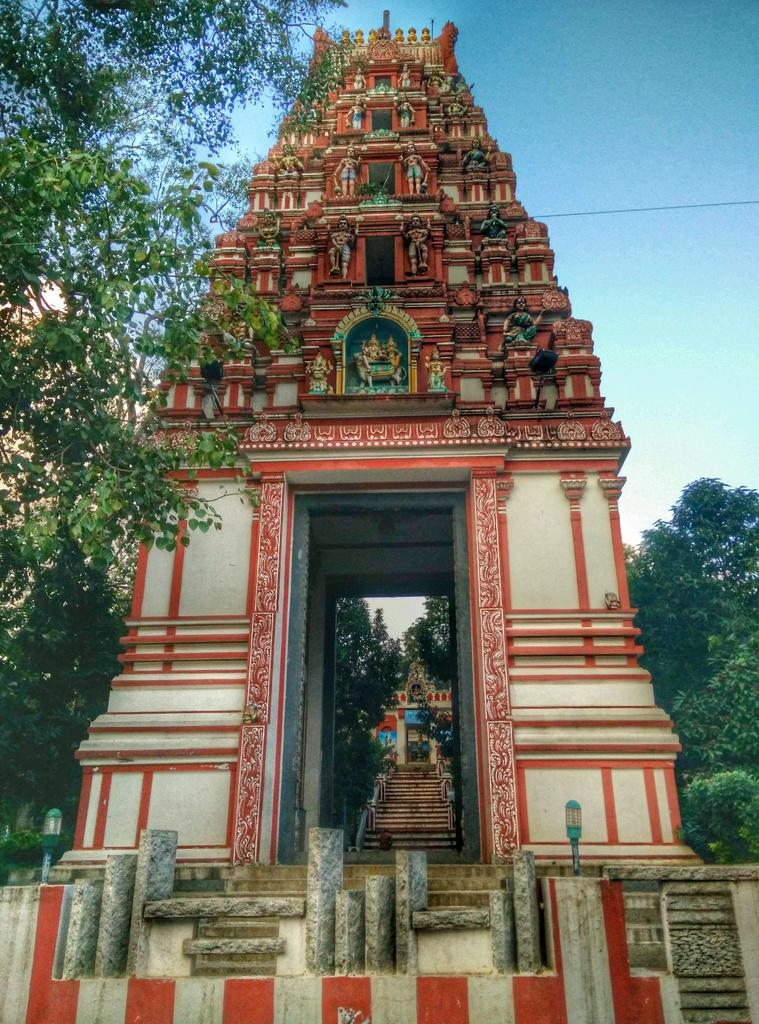What is the main subject in the center of the image? There is a temple entrance door in the center of the image. What architectural feature is present in the image? There are stairs in the image. What can be seen illuminating the area in the image? Lights are present in the image. What type of natural elements are visible in the image? Trees are visible in the image. What recreational activity is depicted at the top of the image? There is a skywire at the top of the image. What type of stone is used to build the bear's den in the image? There are no bears or bear dens present in the image; it features a temple entrance door, stairs, lights, trees, and a skywire. What breakfast items can be seen on the table in the image? There is no table or breakfast items present in the image. 